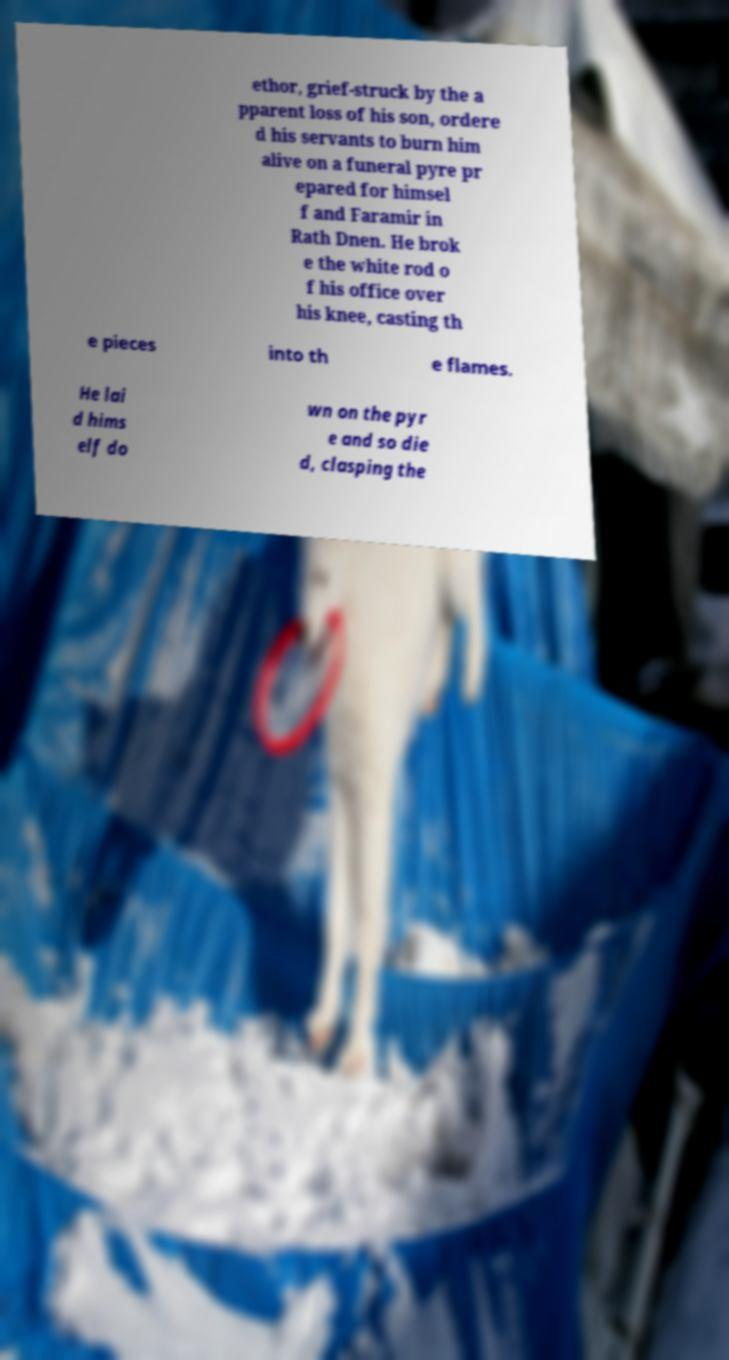Can you accurately transcribe the text from the provided image for me? ethor, grief-struck by the a pparent loss of his son, ordere d his servants to burn him alive on a funeral pyre pr epared for himsel f and Faramir in Rath Dnen. He brok e the white rod o f his office over his knee, casting th e pieces into th e flames. He lai d hims elf do wn on the pyr e and so die d, clasping the 